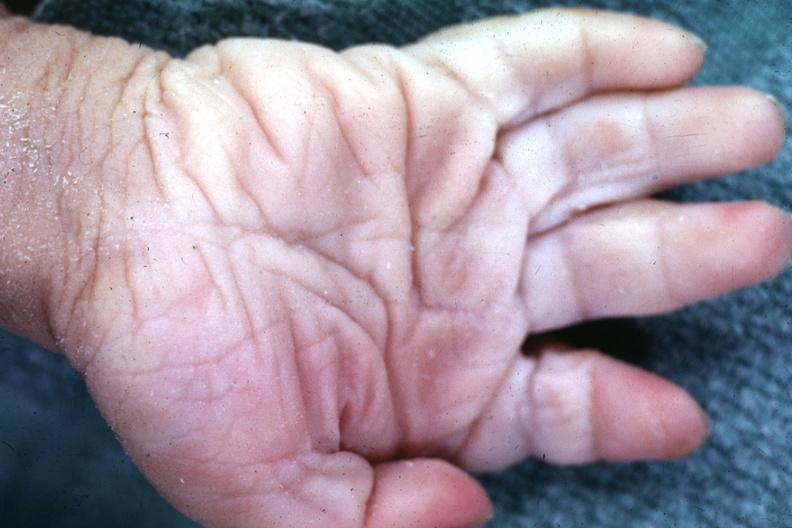s hand present?
Answer the question using a single word or phrase. Yes 